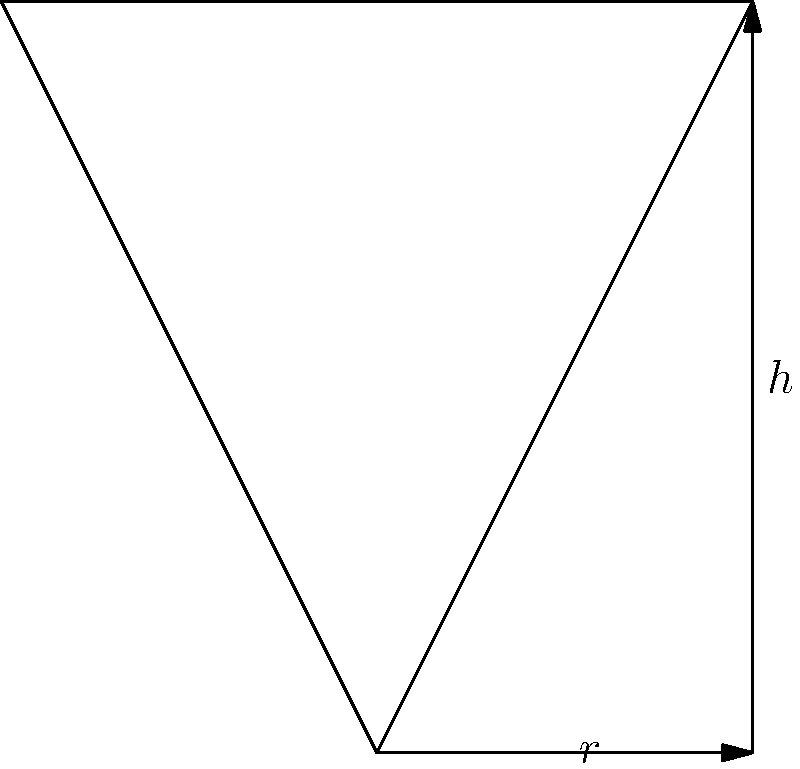As a producer of Middle Eastern spices, you want to design a conical container to store and display your products. The container needs to hold a volume of 200 cubic centimeters. What dimensions (radius and height) should the container have to minimize the surface area of the cone, thus reducing material costs? Round your answer to the nearest tenth of a centimeter. Let's approach this step-by-step:

1) First, we need to express the surface area of a cone in terms of its radius $r$ and height $h$:
   Surface Area = $\pi r^2 + \pi r \sqrt{r^2 + h^2}$

2) We're given that the volume is fixed at 200 cm³. The volume of a cone is:
   $V = \frac{1}{3}\pi r^2h = 200$

3) From this, we can express $h$ in terms of $r$:
   $h = \frac{600}{\pi r^2}$

4) Now, we can rewrite the surface area formula in terms of $r$ only:
   $S(r) = \pi r^2 + \pi r \sqrt{r^2 + (\frac{600}{\pi r^2})^2}$

5) To minimize this, we need to find where its derivative equals zero:
   $S'(r) = 2\pi r + \pi \sqrt{r^2 + (\frac{600}{\pi r^2})^2} + \pi r \cdot \frac{2r^2 - 2(\frac{600}{\pi r^2})^2 \cdot \frac{-2}{\pi r^3}}{2\sqrt{r^2 + (\frac{600}{\pi r^2})^2}}$

6) Setting this equal to zero and solving is complex, but it results in:
   $r = \sqrt[3]{\frac{200}{\pi}} \approx 3.8$ cm

7) We can find $h$ by substituting this back into our equation from step 3:
   $h = \frac{600}{\pi r^2} \approx 13.2$ cm

8) Rounding to the nearest tenth:
   $r \approx 3.8$ cm
   $h \approx 13.2$ cm
Answer: $r \approx 3.8$ cm, $h \approx 13.2$ cm 